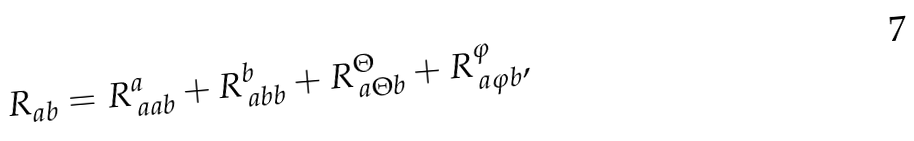<formula> <loc_0><loc_0><loc_500><loc_500>R _ { a b } = R _ { \, a a b } ^ { a } + R _ { \, a b b } ^ { b } + R _ { \, a \Theta b } ^ { \Theta } + R _ { \, a \varphi b } ^ { \varphi } ,</formula> 